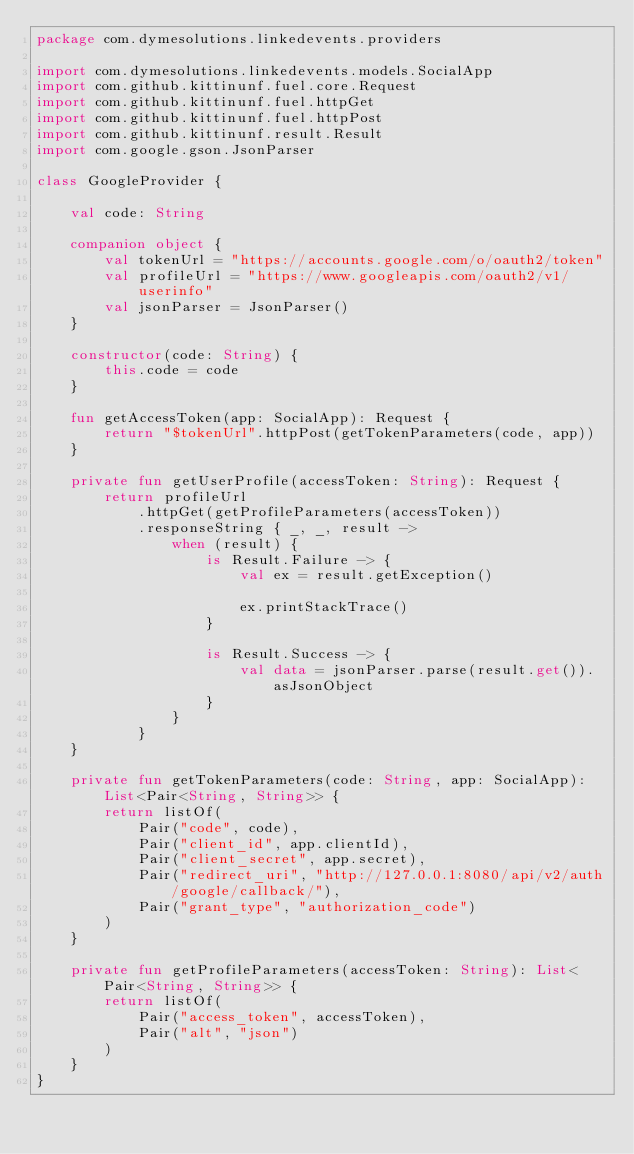Convert code to text. <code><loc_0><loc_0><loc_500><loc_500><_Kotlin_>package com.dymesolutions.linkedevents.providers

import com.dymesolutions.linkedevents.models.SocialApp
import com.github.kittinunf.fuel.core.Request
import com.github.kittinunf.fuel.httpGet
import com.github.kittinunf.fuel.httpPost
import com.github.kittinunf.result.Result
import com.google.gson.JsonParser

class GoogleProvider {

    val code: String

    companion object {
        val tokenUrl = "https://accounts.google.com/o/oauth2/token"
        val profileUrl = "https://www.googleapis.com/oauth2/v1/userinfo"
        val jsonParser = JsonParser()
    }

    constructor(code: String) {
        this.code = code
    }

    fun getAccessToken(app: SocialApp): Request {
        return "$tokenUrl".httpPost(getTokenParameters(code, app))
    }

    private fun getUserProfile(accessToken: String): Request {
        return profileUrl
            .httpGet(getProfileParameters(accessToken))
            .responseString { _, _, result ->
                when (result) {
                    is Result.Failure -> {
                        val ex = result.getException()

                        ex.printStackTrace()
                    }

                    is Result.Success -> {
                        val data = jsonParser.parse(result.get()).asJsonObject
                    }
                }
            }
    }

    private fun getTokenParameters(code: String, app: SocialApp): List<Pair<String, String>> {
        return listOf(
            Pair("code", code),
            Pair("client_id", app.clientId),
            Pair("client_secret", app.secret),
            Pair("redirect_uri", "http://127.0.0.1:8080/api/v2/auth/google/callback/"),
            Pair("grant_type", "authorization_code")
        )
    }

    private fun getProfileParameters(accessToken: String): List<Pair<String, String>> {
        return listOf(
            Pair("access_token", accessToken),
            Pair("alt", "json")
        )
    }
}
</code> 